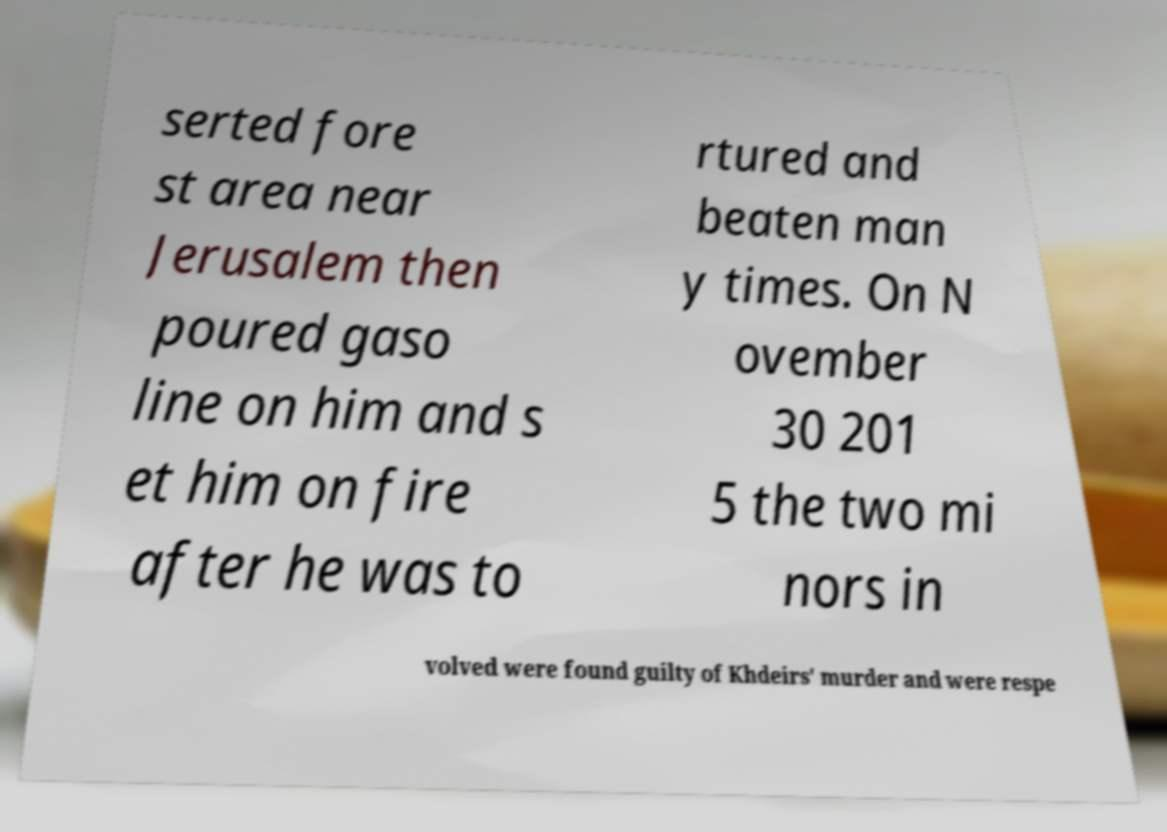There's text embedded in this image that I need extracted. Can you transcribe it verbatim? serted fore st area near Jerusalem then poured gaso line on him and s et him on fire after he was to rtured and beaten man y times. On N ovember 30 201 5 the two mi nors in volved were found guilty of Khdeirs' murder and were respe 